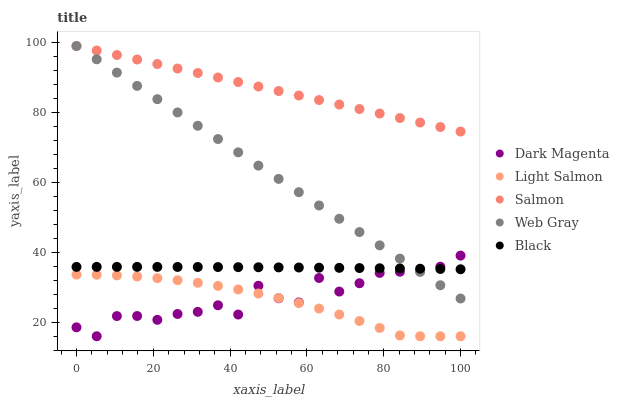Does Light Salmon have the minimum area under the curve?
Answer yes or no. Yes. Does Salmon have the maximum area under the curve?
Answer yes or no. Yes. Does Web Gray have the minimum area under the curve?
Answer yes or no. No. Does Web Gray have the maximum area under the curve?
Answer yes or no. No. Is Web Gray the smoothest?
Answer yes or no. Yes. Is Dark Magenta the roughest?
Answer yes or no. Yes. Is Light Salmon the smoothest?
Answer yes or no. No. Is Light Salmon the roughest?
Answer yes or no. No. Does Light Salmon have the lowest value?
Answer yes or no. Yes. Does Web Gray have the lowest value?
Answer yes or no. No. Does Salmon have the highest value?
Answer yes or no. Yes. Does Light Salmon have the highest value?
Answer yes or no. No. Is Light Salmon less than Black?
Answer yes or no. Yes. Is Salmon greater than Black?
Answer yes or no. Yes. Does Dark Magenta intersect Web Gray?
Answer yes or no. Yes. Is Dark Magenta less than Web Gray?
Answer yes or no. No. Is Dark Magenta greater than Web Gray?
Answer yes or no. No. Does Light Salmon intersect Black?
Answer yes or no. No. 